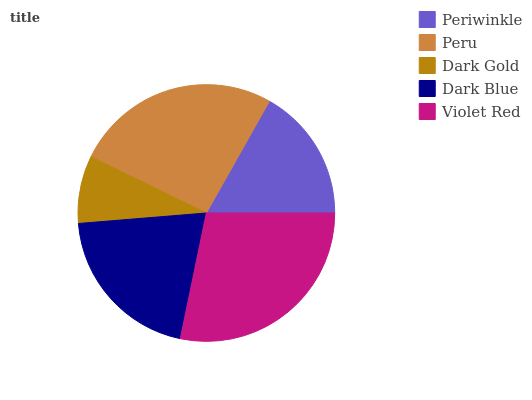Is Dark Gold the minimum?
Answer yes or no. Yes. Is Violet Red the maximum?
Answer yes or no. Yes. Is Peru the minimum?
Answer yes or no. No. Is Peru the maximum?
Answer yes or no. No. Is Peru greater than Periwinkle?
Answer yes or no. Yes. Is Periwinkle less than Peru?
Answer yes or no. Yes. Is Periwinkle greater than Peru?
Answer yes or no. No. Is Peru less than Periwinkle?
Answer yes or no. No. Is Dark Blue the high median?
Answer yes or no. Yes. Is Dark Blue the low median?
Answer yes or no. Yes. Is Violet Red the high median?
Answer yes or no. No. Is Violet Red the low median?
Answer yes or no. No. 